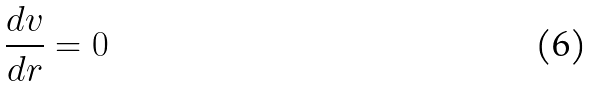Convert formula to latex. <formula><loc_0><loc_0><loc_500><loc_500>\frac { d v } { d r } = 0</formula> 